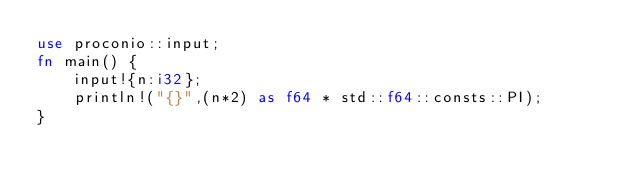<code> <loc_0><loc_0><loc_500><loc_500><_Rust_>use proconio::input;
fn main() {
    input!{n:i32};
    println!("{}",(n*2) as f64 * std::f64::consts::PI);
}
</code> 